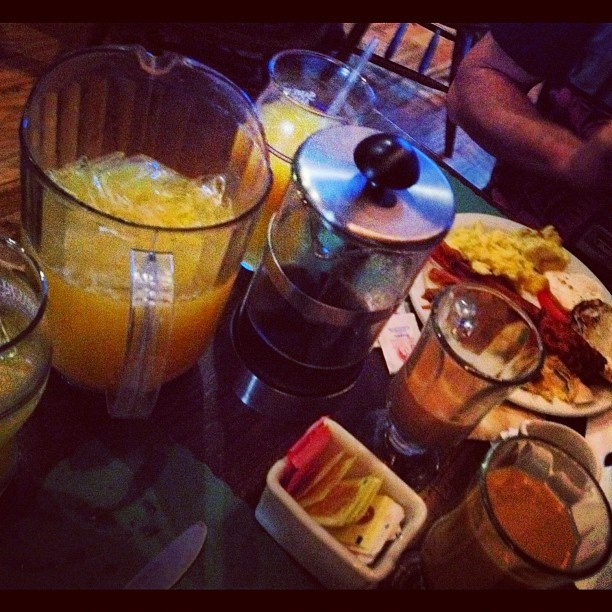Describe the objects in this image and their specific colors. I can see cup in black, maroon, olive, and tan tones, dining table in black, maroon, and purple tones, people in black, maroon, purple, and brown tones, cup in black, maroon, and brown tones, and wine glass in black, maroon, and brown tones in this image. 